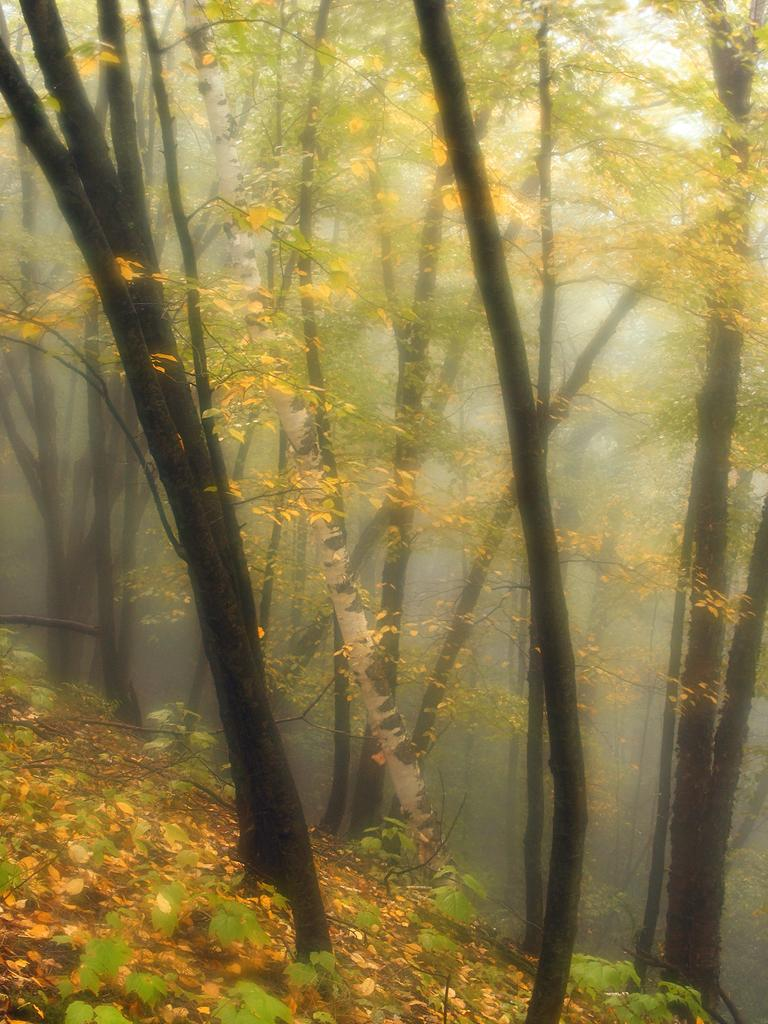What type of vegetation can be seen in the image? There are trees and plants in the image. Can you describe the background of the image? The background of the image is slightly blurred. What suggestion does the maid make in the image? There is no maid present in the image, so no suggestion can be made. 